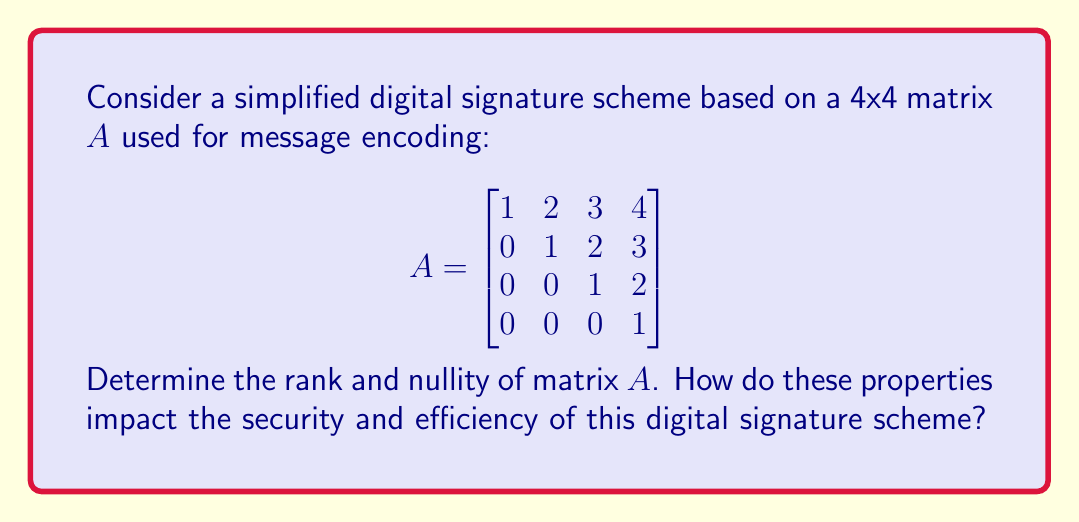Can you solve this math problem? To find the rank and nullity of matrix $A$, we'll follow these steps:

1) First, let's recall that for an $n \times n$ matrix, rank + nullity = $n$.

2) To find the rank, we need to determine the number of linearly independent rows or columns. We can do this by reducing the matrix to row echelon form:

   $$A = \begin{bmatrix}
   1 & 2 & 3 & 4 \\
   0 & 1 & 2 & 3 \\
   0 & 0 & 1 & 2 \\
   0 & 0 & 0 & 1
   \end{bmatrix}$$

3) We can see that the matrix is already in row echelon form, and all rows are non-zero.

4) The number of non-zero rows in the row echelon form is the rank of the matrix. Here, all 4 rows are non-zero, so:

   $rank(A) = 4$

5) Given that rank + nullity = $n$ for an $n \times n$ matrix, and $n = 4$ here:

   $4 + nullity(A) = 4$
   $nullity(A) = 0$

6) Impact on the digital signature scheme:
   - Rank = 4 means the transformation is injective (one-to-one), ensuring unique signatures for different messages.
   - Nullity = 0 implies the kernel only contains the zero vector, meaning no non-zero message will produce a zero signature.
   - Full rank (4) indicates maximum information preservation during encoding, enhancing security.
   - The upper triangular structure allows for efficient signature generation and verification through back-substitution.
Answer: Rank = 4, Nullity = 0 